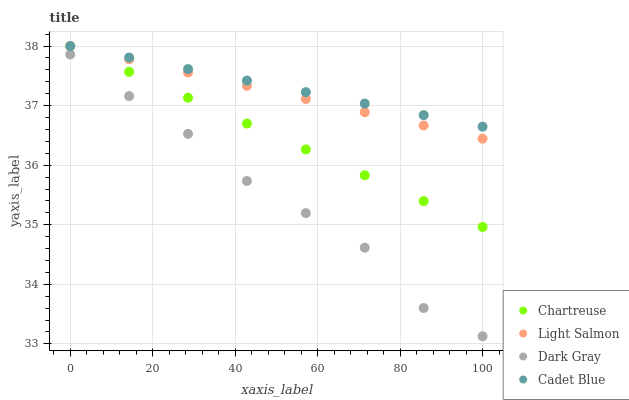Does Dark Gray have the minimum area under the curve?
Answer yes or no. Yes. Does Cadet Blue have the maximum area under the curve?
Answer yes or no. Yes. Does Chartreuse have the minimum area under the curve?
Answer yes or no. No. Does Chartreuse have the maximum area under the curve?
Answer yes or no. No. Is Light Salmon the smoothest?
Answer yes or no. Yes. Is Dark Gray the roughest?
Answer yes or no. Yes. Is Chartreuse the smoothest?
Answer yes or no. No. Is Chartreuse the roughest?
Answer yes or no. No. Does Dark Gray have the lowest value?
Answer yes or no. Yes. Does Chartreuse have the lowest value?
Answer yes or no. No. Does Light Salmon have the highest value?
Answer yes or no. Yes. Is Dark Gray less than Cadet Blue?
Answer yes or no. Yes. Is Cadet Blue greater than Dark Gray?
Answer yes or no. Yes. Does Light Salmon intersect Cadet Blue?
Answer yes or no. Yes. Is Light Salmon less than Cadet Blue?
Answer yes or no. No. Is Light Salmon greater than Cadet Blue?
Answer yes or no. No. Does Dark Gray intersect Cadet Blue?
Answer yes or no. No. 